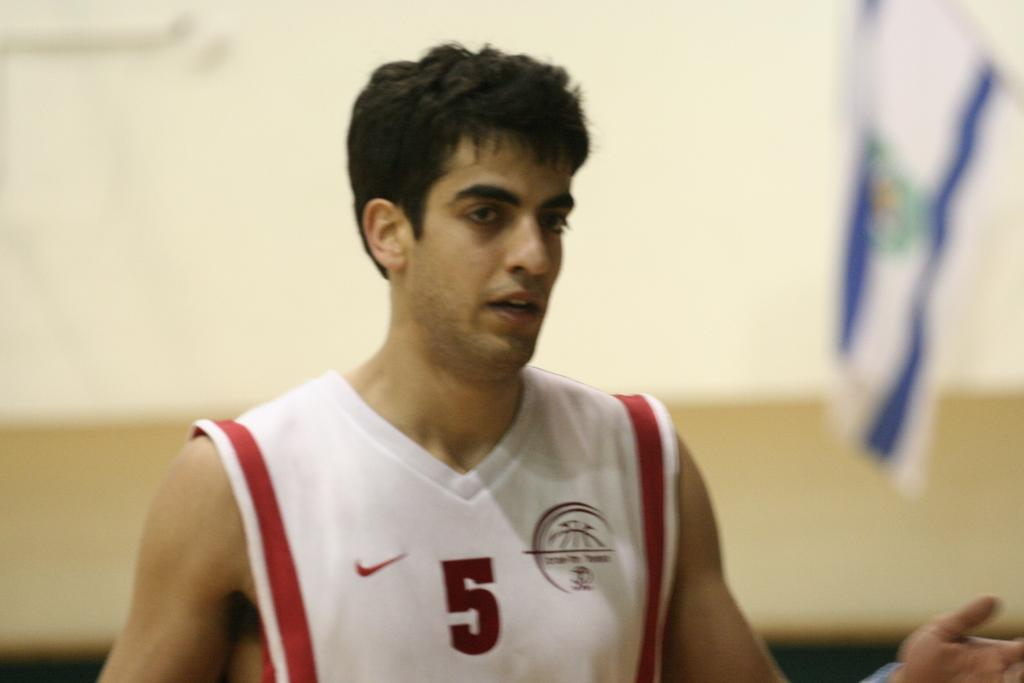What is the person in the image wearing? The person in the image is wearing a white t-shirt. Where is the person located in the image? The person is in the middle of the image. What can be seen in the background of the image? There is a flag in the background of the image. How would you describe the background of the image? The background is blurred. What type of dinner is the person in the image preparing? There is no indication in the image that the person is preparing dinner, so it cannot be determined from the picture. 